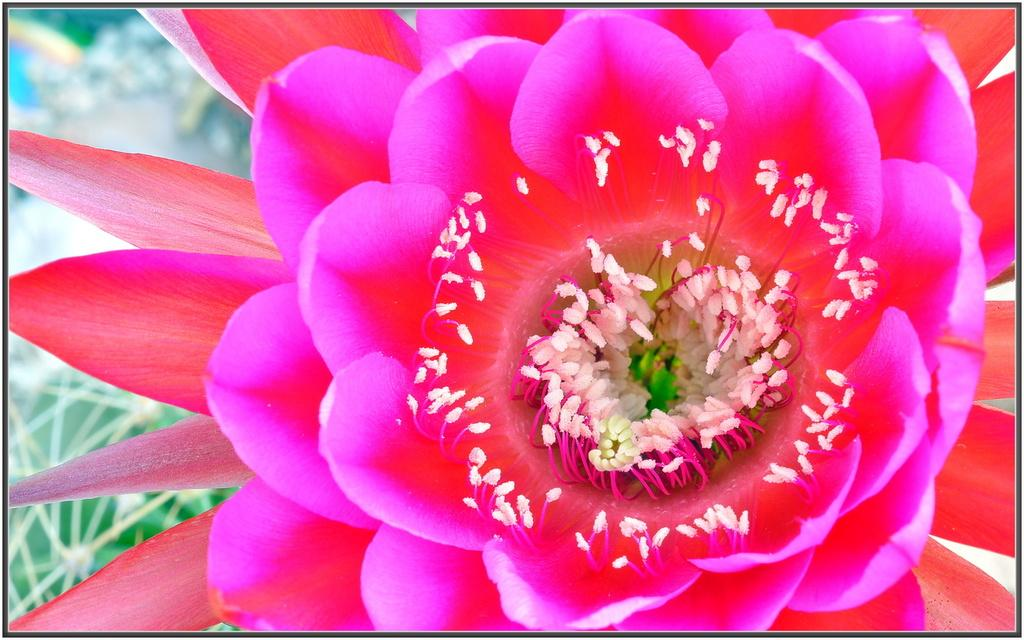What is the main subject of the picture? The main subject of the picture is a flower. Can you describe the color of the flower? The flower is red and pink in color. How would you describe the background of the image? The background of the image is blurred. What type of operation is being performed on the flower in the image? There is no operation being performed on the flower in the image. 